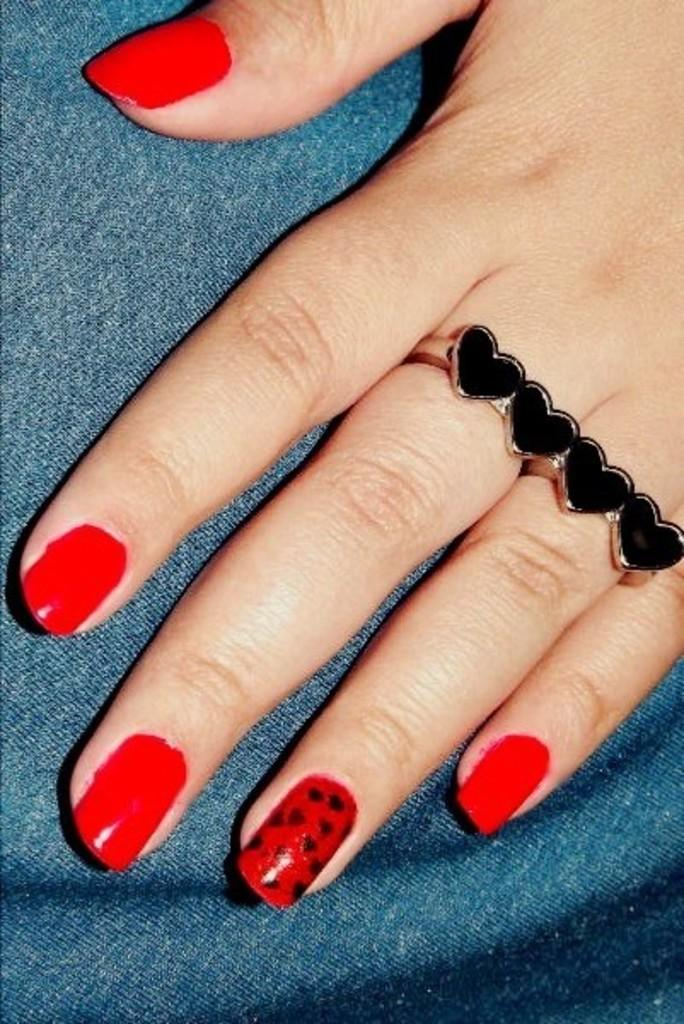What part of the human body is visible in the image? There is a human hand in the image. What is on the hand in the image? There is a finger ring on the hand. What is the hand holding in the image? The hand is holding a piece of cloth. What is the color of the nail polish on the finger? The nail polish on the finger is red in color. What type of mist can be seen surrounding the hand in the image? There is no mist present in the image; it is a clear image of a hand holding a piece of cloth. 